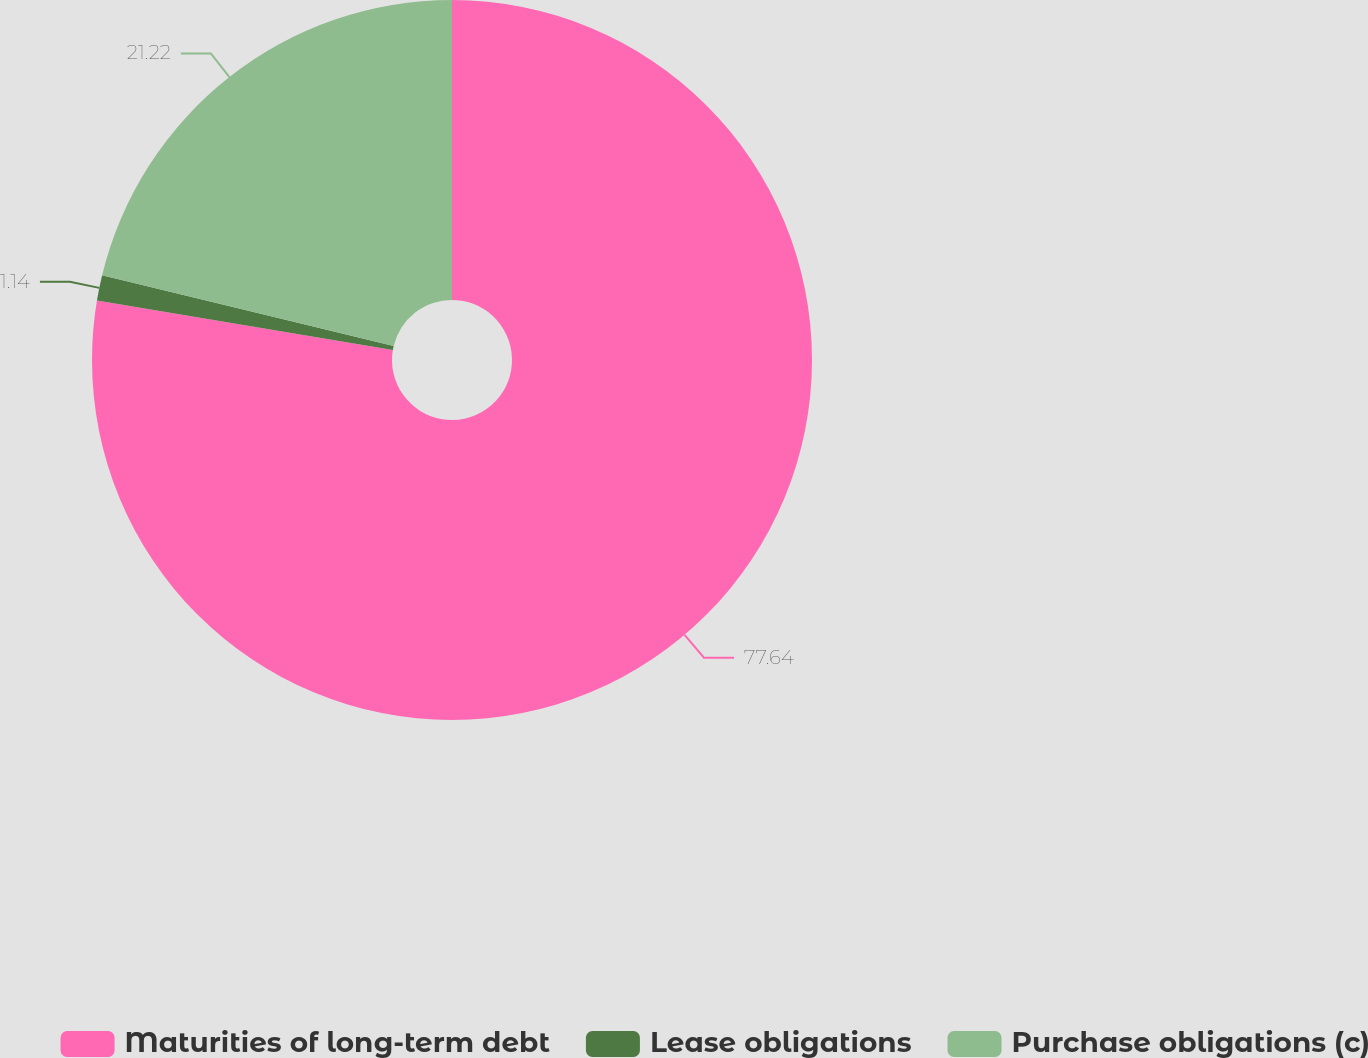Convert chart to OTSL. <chart><loc_0><loc_0><loc_500><loc_500><pie_chart><fcel>Maturities of long-term debt<fcel>Lease obligations<fcel>Purchase obligations (c)<nl><fcel>77.64%<fcel>1.14%<fcel>21.22%<nl></chart> 